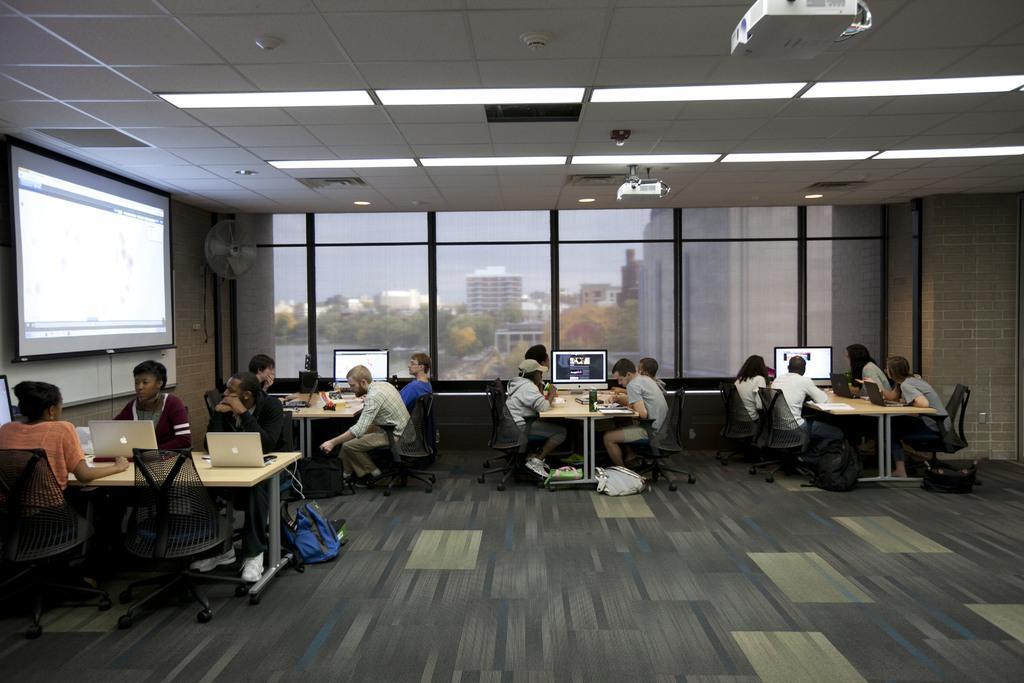How would you summarize this image in a sentence or two? In this image there are four tables and few chairs placed near them. On the top of the tables there are laptops and monitor screens and few things placed. In the background of the image there are few buildings and trees. In the left side of the image there is a projector screen and there is a fan. This is a ceiling roof. 